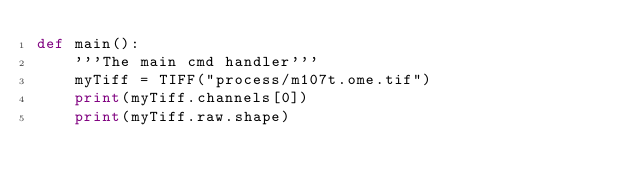<code> <loc_0><loc_0><loc_500><loc_500><_Python_>def main():
    '''The main cmd handler'''
    myTiff = TIFF("process/m107t.ome.tif")
    print(myTiff.channels[0])
    print(myTiff.raw.shape)</code> 